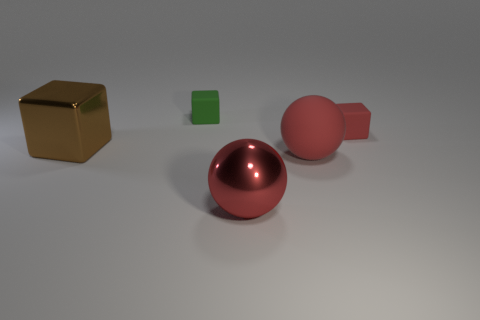Subtract all blue cubes. Subtract all green spheres. How many cubes are left? 3 Add 3 green matte things. How many objects exist? 8 Subtract all blocks. How many objects are left? 2 Add 4 green rubber things. How many green rubber things exist? 5 Subtract 0 red cylinders. How many objects are left? 5 Subtract all green matte cubes. Subtract all tiny rubber things. How many objects are left? 2 Add 4 matte cubes. How many matte cubes are left? 6 